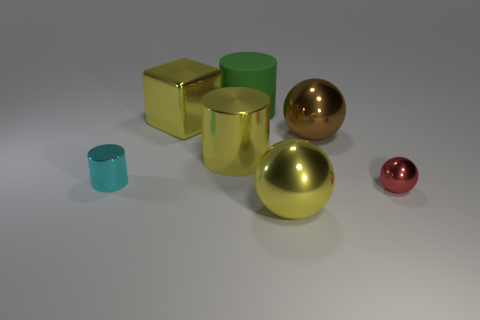There is a block that is the same color as the large shiny cylinder; what is its size?
Offer a very short reply. Large. Is the number of large yellow metallic cylinders greater than the number of brown metal cubes?
Give a very brief answer. Yes. Is the large rubber object the same color as the big shiny cube?
Offer a very short reply. No. How many objects are either big yellow cubes or big objects that are behind the small red thing?
Provide a short and direct response. 4. What number of other things are the same shape as the red object?
Your answer should be compact. 2. Is the number of red metallic things that are on the left side of the big block less than the number of large balls that are on the left side of the matte thing?
Keep it short and to the point. No. Is there any other thing that has the same material as the cyan thing?
Your answer should be compact. Yes. What shape is the tiny red object that is the same material as the large brown thing?
Your answer should be very brief. Sphere. Are there any other things that have the same color as the big matte cylinder?
Offer a very short reply. No. There is a large sphere that is behind the big metal thing that is in front of the yellow cylinder; what color is it?
Provide a succinct answer. Brown. 